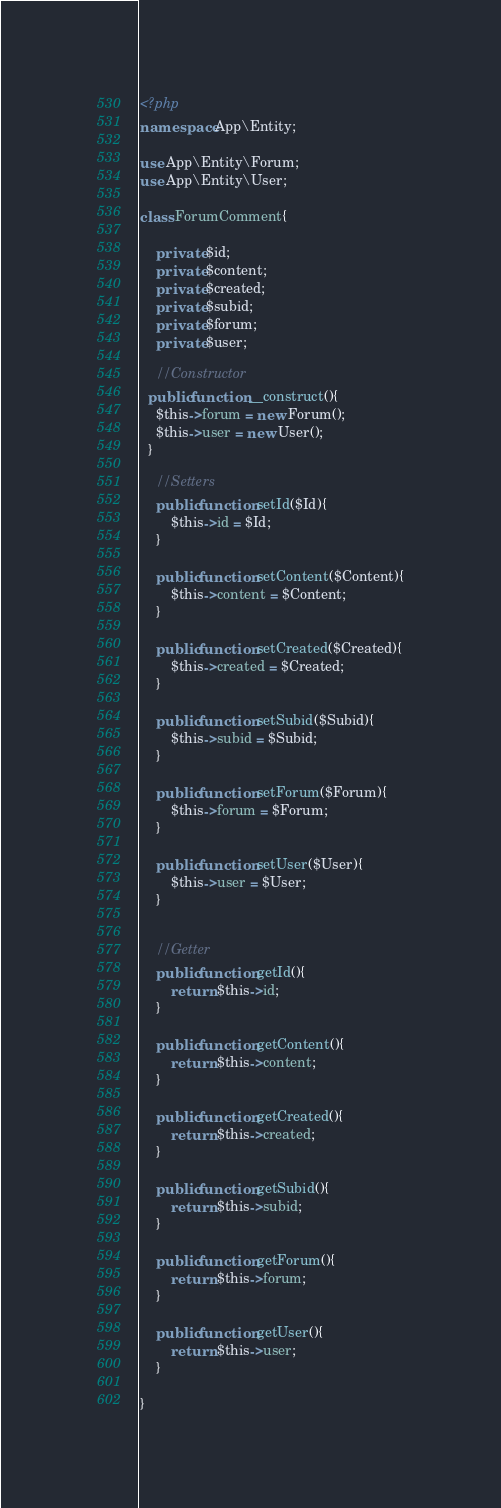<code> <loc_0><loc_0><loc_500><loc_500><_PHP_><?php
namespace App\Entity;

use App\Entity\Forum;
use App\Entity\User;

class ForumComment{

	private $id;
	private $content;
	private $created;
	private $subid;
	private $forum;
	private $user;

	//Constructor
  public function __construct(){
    $this->forum = new Forum();
    $this->user = new User();
  }

	//Setters
	public function setId($Id){
		$this->id = $Id;
	}

	public function setContent($Content){
		$this->content = $Content;
	}

	public function setCreated($Created){
		$this->created = $Created;
	}

	public function setSubid($Subid){
		$this->subid = $Subid;
	}

	public function setForum($Forum){
		$this->forum = $Forum;
	}

	public function setUser($User){
		$this->user = $User;
	}


	//Getter
	public function getId(){
		return $this->id;
	}

	public function getContent(){
		return $this->content;
	}

	public function getCreated(){
		return $this->created;
	}

	public function getSubid(){
		return $this->subid;
	}

	public function getForum(){
		return $this->forum;
	}

	public function getUser(){
		return $this->user;
	}

}
</code> 